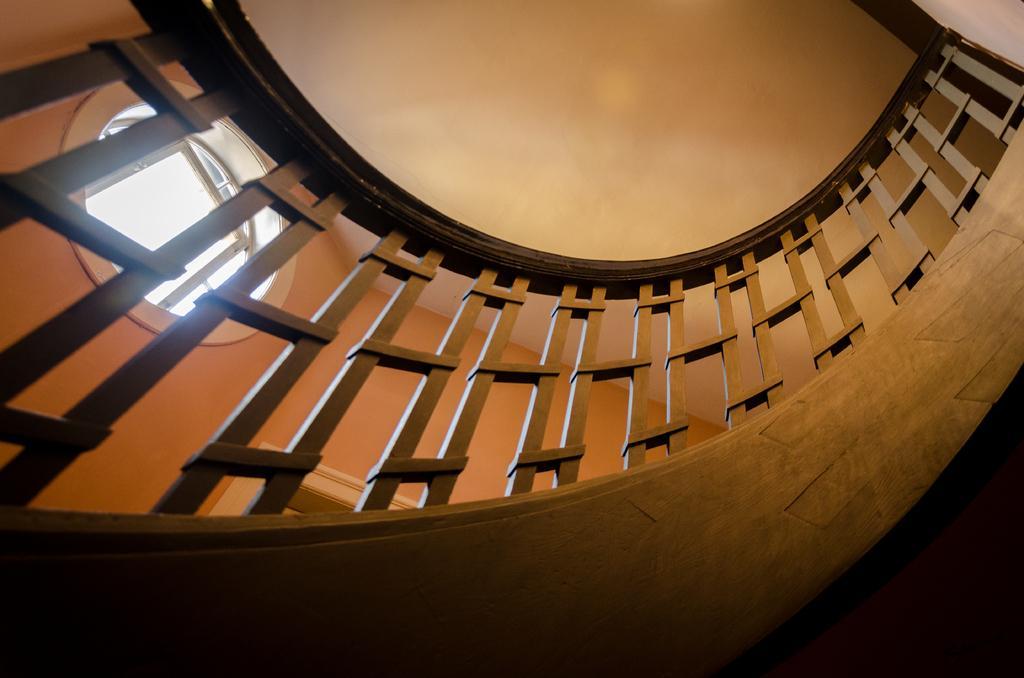Could you give a brief overview of what you see in this image? In the foreground of this picture we can see the railing and at the top we can see the roof and in the background we can see the wall and the window. 